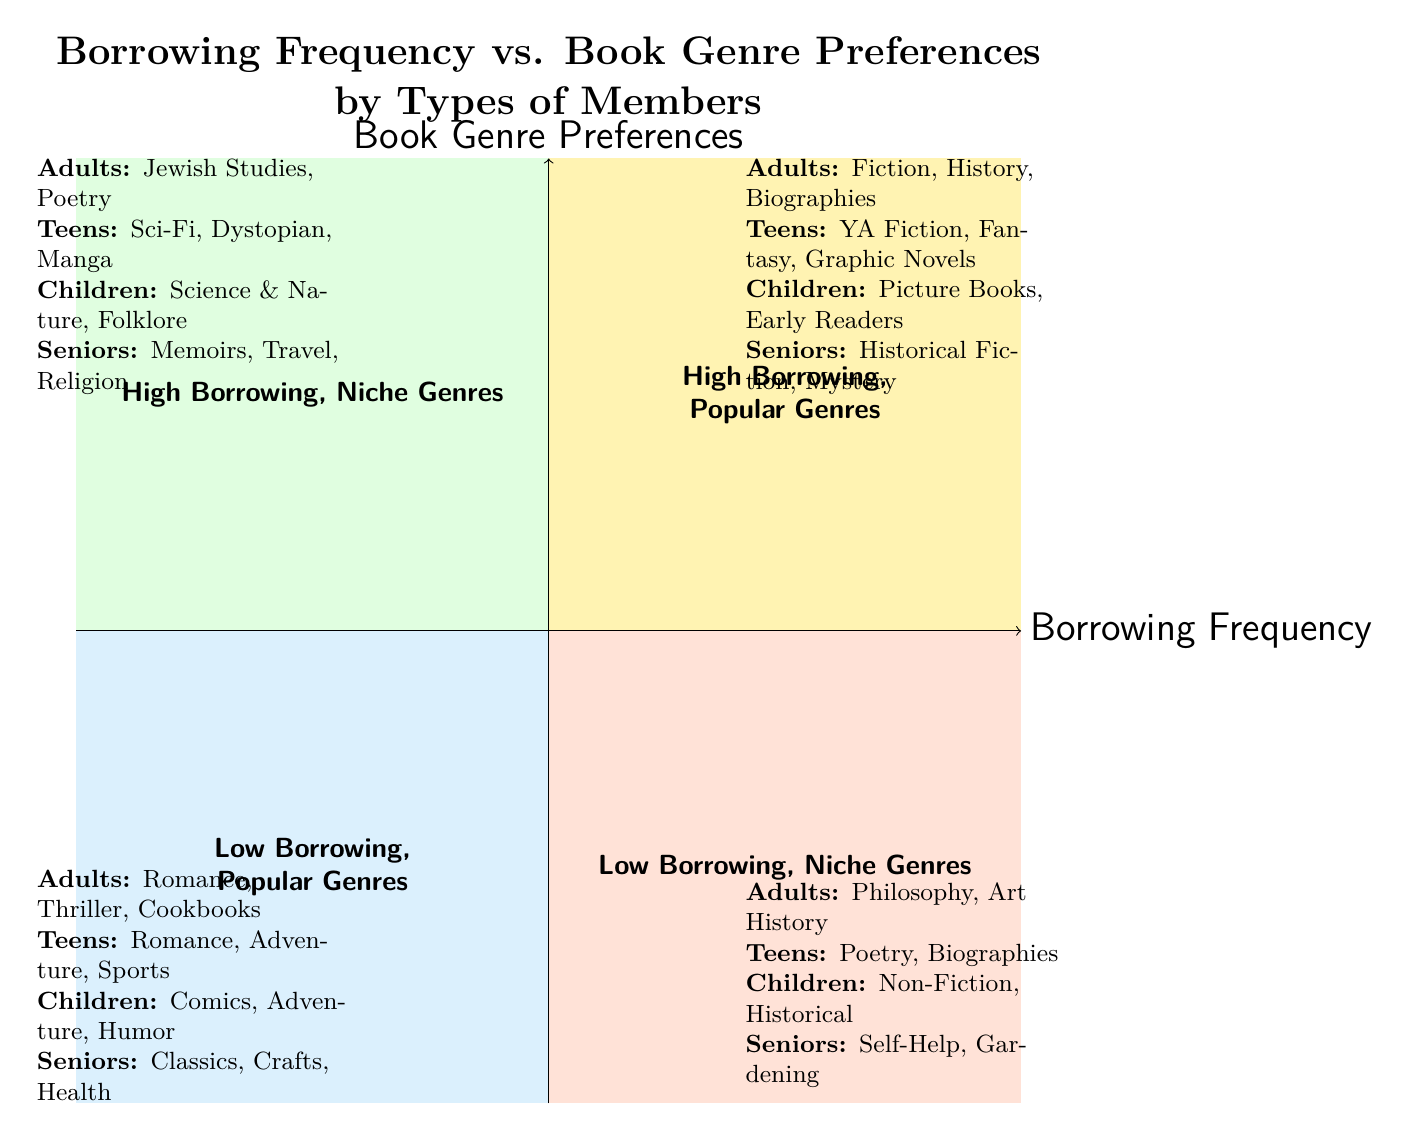What genres do adults prefer when borrowing frequently? According to the diagram, in Quadrant 1 where there is high borrowing frequency and popular genres, adults prefer "Fiction," "History," and "Biographies."
Answer: Fiction, History, Biographies Which quadrant contains children's preferences for educational books? In Quadrant 2, which represents high borrowing frequency and niche genres, children have a preference for "Science & Nature," "Folklore," and "Educational" books.
Answer: High Borrowing Frequency, Niche Genres How many types of members are analyzed in this diagram? The diagram segments members into four types: adults, teens, children, and seniors. This is indicated by distinct genre preferences assigned to each member type.
Answer: Four What genre is associated with low borrowing frequency for seniors? In Quadrant 4, which details low borrowing frequency and niche genres, seniors prefer "Self-Help," "Gardening," and "Mindfulness."
Answer: Self-Help, Gardening, Mindfulness Which genre is most preferred by teens who borrow frequently? In Quadrant 1, where there's high borrowing frequency and popular genres, teens prefer "Young Adult Fiction," "Fantasy," and "Graphic Novels."
Answer: Young Adult Fiction, Fantasy, Graphic Novels What is the relationship between children's borrowing frequency and their genre preferences? The diagram indicates that children's preferences for educational genres fall under High Borrowing Frequency, Niche Genres (Quadrant 2), indicating a strong interest in certain topics alongside an eagerness to borrow.
Answer: High Borrowing Frequency with Niche Genres Which quadrant represents low borrowing frequency and popular genres? Quadrant 3 is described in the diagram as containing low borrowing frequency and popular genres. This quadrant includes various genres for different member types.
Answer: Low Borrowing, Popular Genres What genre is favored by seniors who borrow less frequently? In Quadrant 3, seniors tend to favor "Classics," "Crafts & Hobbies," and "Health," indicating their preferences in popular genres despite lower borrowing frequency.
Answer: Classics, Crafts & Hobbies, Health What genre preferences do teens have in a high borrowing frequency and niche genre context? For teens in Quadrant 2, which is characterized by high borrowing frequency and niche genres, their preferences include "Science Fiction," "Dystopian," and "Manga."
Answer: Science Fiction, Dystopian, Manga 